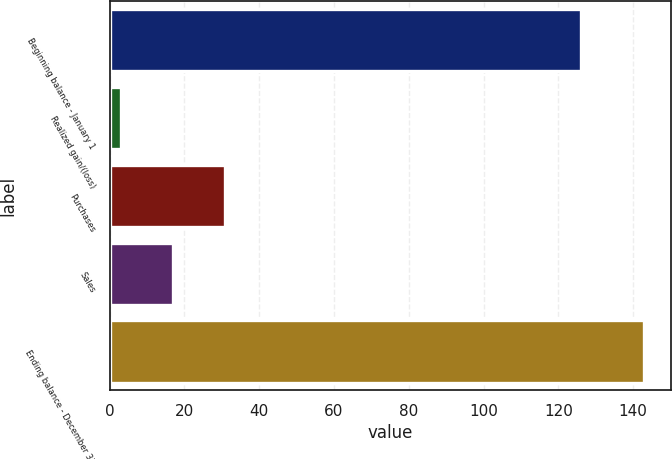Convert chart. <chart><loc_0><loc_0><loc_500><loc_500><bar_chart><fcel>Beginning balance - January 1<fcel>Realized gain/(loss)<fcel>Purchases<fcel>Sales<fcel>Ending balance - December 31<nl><fcel>126<fcel>3<fcel>31<fcel>17<fcel>143<nl></chart> 